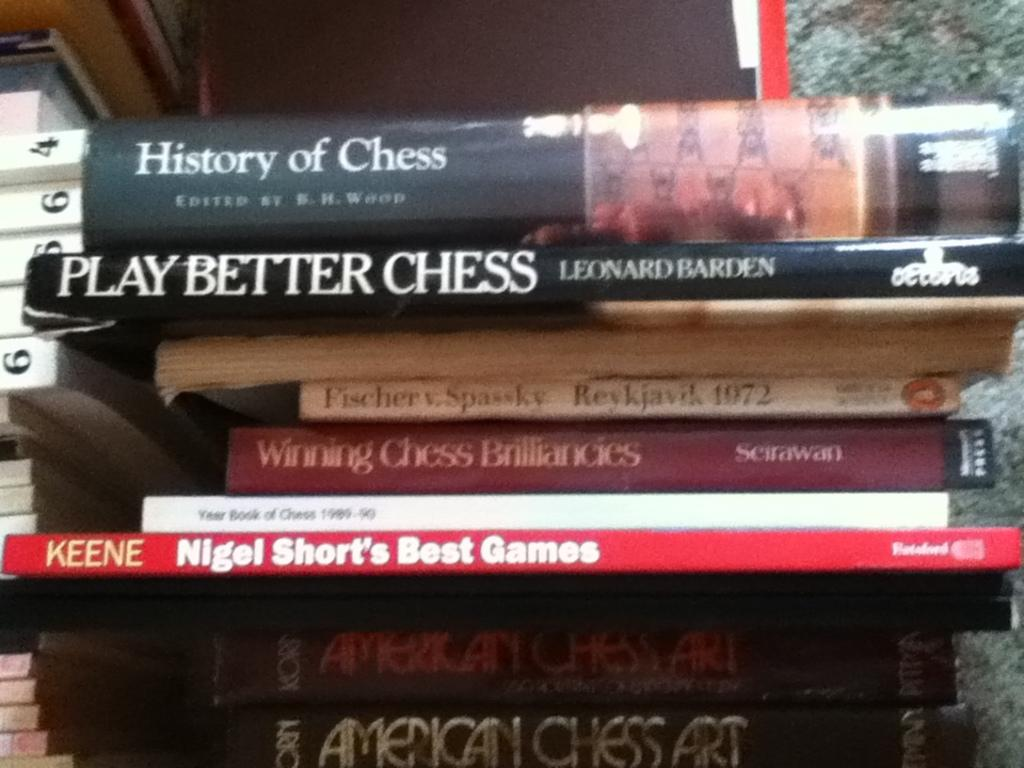<image>
Give a short and clear explanation of the subsequent image. A stack of books are on the topic of chess and include the title History of Chess. 